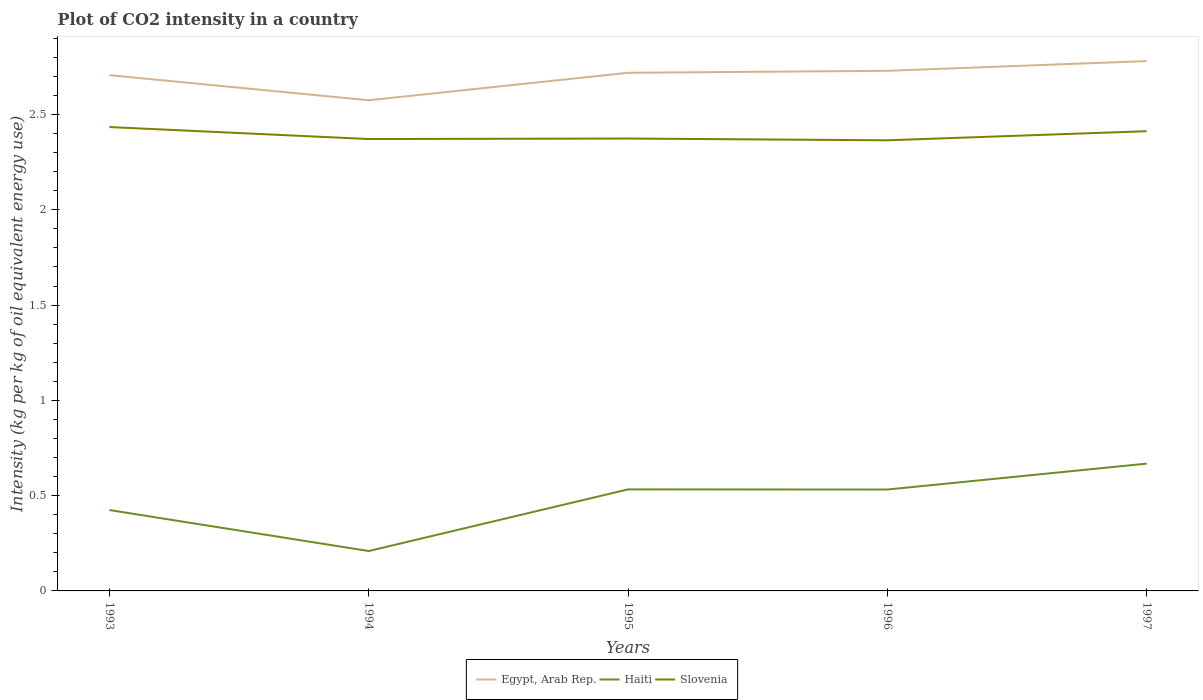How many different coloured lines are there?
Offer a terse response. 3. Does the line corresponding to Haiti intersect with the line corresponding to Egypt, Arab Rep.?
Ensure brevity in your answer.  No. Is the number of lines equal to the number of legend labels?
Keep it short and to the point. Yes. Across all years, what is the maximum CO2 intensity in in Haiti?
Provide a succinct answer. 0.21. What is the total CO2 intensity in in Slovenia in the graph?
Your answer should be very brief. 0.07. What is the difference between the highest and the second highest CO2 intensity in in Haiti?
Provide a short and direct response. 0.46. Is the CO2 intensity in in Haiti strictly greater than the CO2 intensity in in Slovenia over the years?
Your response must be concise. Yes. How many years are there in the graph?
Your answer should be very brief. 5. What is the difference between two consecutive major ticks on the Y-axis?
Provide a short and direct response. 0.5. Are the values on the major ticks of Y-axis written in scientific E-notation?
Give a very brief answer. No. Does the graph contain any zero values?
Offer a terse response. No. Where does the legend appear in the graph?
Offer a very short reply. Bottom center. How are the legend labels stacked?
Give a very brief answer. Horizontal. What is the title of the graph?
Keep it short and to the point. Plot of CO2 intensity in a country. Does "Bulgaria" appear as one of the legend labels in the graph?
Provide a succinct answer. No. What is the label or title of the X-axis?
Provide a short and direct response. Years. What is the label or title of the Y-axis?
Keep it short and to the point. Intensity (kg per kg of oil equivalent energy use). What is the Intensity (kg per kg of oil equivalent energy use) in Egypt, Arab Rep. in 1993?
Make the answer very short. 2.71. What is the Intensity (kg per kg of oil equivalent energy use) of Haiti in 1993?
Keep it short and to the point. 0.42. What is the Intensity (kg per kg of oil equivalent energy use) in Slovenia in 1993?
Your answer should be very brief. 2.43. What is the Intensity (kg per kg of oil equivalent energy use) of Egypt, Arab Rep. in 1994?
Offer a very short reply. 2.57. What is the Intensity (kg per kg of oil equivalent energy use) in Haiti in 1994?
Make the answer very short. 0.21. What is the Intensity (kg per kg of oil equivalent energy use) in Slovenia in 1994?
Ensure brevity in your answer.  2.37. What is the Intensity (kg per kg of oil equivalent energy use) of Egypt, Arab Rep. in 1995?
Make the answer very short. 2.72. What is the Intensity (kg per kg of oil equivalent energy use) in Haiti in 1995?
Offer a very short reply. 0.53. What is the Intensity (kg per kg of oil equivalent energy use) in Slovenia in 1995?
Give a very brief answer. 2.37. What is the Intensity (kg per kg of oil equivalent energy use) of Egypt, Arab Rep. in 1996?
Your response must be concise. 2.73. What is the Intensity (kg per kg of oil equivalent energy use) of Haiti in 1996?
Offer a terse response. 0.53. What is the Intensity (kg per kg of oil equivalent energy use) in Slovenia in 1996?
Give a very brief answer. 2.36. What is the Intensity (kg per kg of oil equivalent energy use) in Egypt, Arab Rep. in 1997?
Your response must be concise. 2.78. What is the Intensity (kg per kg of oil equivalent energy use) of Haiti in 1997?
Your answer should be compact. 0.67. What is the Intensity (kg per kg of oil equivalent energy use) in Slovenia in 1997?
Provide a succinct answer. 2.41. Across all years, what is the maximum Intensity (kg per kg of oil equivalent energy use) in Egypt, Arab Rep.?
Your answer should be compact. 2.78. Across all years, what is the maximum Intensity (kg per kg of oil equivalent energy use) of Haiti?
Ensure brevity in your answer.  0.67. Across all years, what is the maximum Intensity (kg per kg of oil equivalent energy use) of Slovenia?
Give a very brief answer. 2.43. Across all years, what is the minimum Intensity (kg per kg of oil equivalent energy use) in Egypt, Arab Rep.?
Make the answer very short. 2.57. Across all years, what is the minimum Intensity (kg per kg of oil equivalent energy use) in Haiti?
Keep it short and to the point. 0.21. Across all years, what is the minimum Intensity (kg per kg of oil equivalent energy use) of Slovenia?
Offer a very short reply. 2.36. What is the total Intensity (kg per kg of oil equivalent energy use) in Egypt, Arab Rep. in the graph?
Offer a very short reply. 13.51. What is the total Intensity (kg per kg of oil equivalent energy use) in Haiti in the graph?
Provide a short and direct response. 2.37. What is the total Intensity (kg per kg of oil equivalent energy use) of Slovenia in the graph?
Keep it short and to the point. 11.96. What is the difference between the Intensity (kg per kg of oil equivalent energy use) in Egypt, Arab Rep. in 1993 and that in 1994?
Give a very brief answer. 0.13. What is the difference between the Intensity (kg per kg of oil equivalent energy use) in Haiti in 1993 and that in 1994?
Keep it short and to the point. 0.22. What is the difference between the Intensity (kg per kg of oil equivalent energy use) of Slovenia in 1993 and that in 1994?
Your answer should be very brief. 0.06. What is the difference between the Intensity (kg per kg of oil equivalent energy use) of Egypt, Arab Rep. in 1993 and that in 1995?
Keep it short and to the point. -0.01. What is the difference between the Intensity (kg per kg of oil equivalent energy use) of Haiti in 1993 and that in 1995?
Provide a succinct answer. -0.11. What is the difference between the Intensity (kg per kg of oil equivalent energy use) of Slovenia in 1993 and that in 1995?
Give a very brief answer. 0.06. What is the difference between the Intensity (kg per kg of oil equivalent energy use) in Egypt, Arab Rep. in 1993 and that in 1996?
Your response must be concise. -0.02. What is the difference between the Intensity (kg per kg of oil equivalent energy use) of Haiti in 1993 and that in 1996?
Keep it short and to the point. -0.11. What is the difference between the Intensity (kg per kg of oil equivalent energy use) of Slovenia in 1993 and that in 1996?
Ensure brevity in your answer.  0.07. What is the difference between the Intensity (kg per kg of oil equivalent energy use) in Egypt, Arab Rep. in 1993 and that in 1997?
Provide a short and direct response. -0.07. What is the difference between the Intensity (kg per kg of oil equivalent energy use) in Haiti in 1993 and that in 1997?
Keep it short and to the point. -0.24. What is the difference between the Intensity (kg per kg of oil equivalent energy use) in Slovenia in 1993 and that in 1997?
Make the answer very short. 0.02. What is the difference between the Intensity (kg per kg of oil equivalent energy use) in Egypt, Arab Rep. in 1994 and that in 1995?
Provide a succinct answer. -0.14. What is the difference between the Intensity (kg per kg of oil equivalent energy use) of Haiti in 1994 and that in 1995?
Ensure brevity in your answer.  -0.32. What is the difference between the Intensity (kg per kg of oil equivalent energy use) in Slovenia in 1994 and that in 1995?
Provide a short and direct response. -0. What is the difference between the Intensity (kg per kg of oil equivalent energy use) of Egypt, Arab Rep. in 1994 and that in 1996?
Provide a short and direct response. -0.15. What is the difference between the Intensity (kg per kg of oil equivalent energy use) of Haiti in 1994 and that in 1996?
Your answer should be compact. -0.32. What is the difference between the Intensity (kg per kg of oil equivalent energy use) in Slovenia in 1994 and that in 1996?
Your answer should be very brief. 0.01. What is the difference between the Intensity (kg per kg of oil equivalent energy use) of Egypt, Arab Rep. in 1994 and that in 1997?
Keep it short and to the point. -0.21. What is the difference between the Intensity (kg per kg of oil equivalent energy use) in Haiti in 1994 and that in 1997?
Your answer should be compact. -0.46. What is the difference between the Intensity (kg per kg of oil equivalent energy use) of Slovenia in 1994 and that in 1997?
Your response must be concise. -0.04. What is the difference between the Intensity (kg per kg of oil equivalent energy use) in Egypt, Arab Rep. in 1995 and that in 1996?
Ensure brevity in your answer.  -0.01. What is the difference between the Intensity (kg per kg of oil equivalent energy use) of Haiti in 1995 and that in 1996?
Provide a short and direct response. 0. What is the difference between the Intensity (kg per kg of oil equivalent energy use) in Slovenia in 1995 and that in 1996?
Provide a short and direct response. 0.01. What is the difference between the Intensity (kg per kg of oil equivalent energy use) of Egypt, Arab Rep. in 1995 and that in 1997?
Offer a terse response. -0.06. What is the difference between the Intensity (kg per kg of oil equivalent energy use) of Haiti in 1995 and that in 1997?
Ensure brevity in your answer.  -0.14. What is the difference between the Intensity (kg per kg of oil equivalent energy use) in Slovenia in 1995 and that in 1997?
Offer a very short reply. -0.04. What is the difference between the Intensity (kg per kg of oil equivalent energy use) of Egypt, Arab Rep. in 1996 and that in 1997?
Provide a short and direct response. -0.05. What is the difference between the Intensity (kg per kg of oil equivalent energy use) in Haiti in 1996 and that in 1997?
Offer a terse response. -0.14. What is the difference between the Intensity (kg per kg of oil equivalent energy use) in Slovenia in 1996 and that in 1997?
Your answer should be compact. -0.05. What is the difference between the Intensity (kg per kg of oil equivalent energy use) of Egypt, Arab Rep. in 1993 and the Intensity (kg per kg of oil equivalent energy use) of Haiti in 1994?
Make the answer very short. 2.5. What is the difference between the Intensity (kg per kg of oil equivalent energy use) in Egypt, Arab Rep. in 1993 and the Intensity (kg per kg of oil equivalent energy use) in Slovenia in 1994?
Give a very brief answer. 0.34. What is the difference between the Intensity (kg per kg of oil equivalent energy use) in Haiti in 1993 and the Intensity (kg per kg of oil equivalent energy use) in Slovenia in 1994?
Ensure brevity in your answer.  -1.95. What is the difference between the Intensity (kg per kg of oil equivalent energy use) in Egypt, Arab Rep. in 1993 and the Intensity (kg per kg of oil equivalent energy use) in Haiti in 1995?
Provide a succinct answer. 2.17. What is the difference between the Intensity (kg per kg of oil equivalent energy use) of Egypt, Arab Rep. in 1993 and the Intensity (kg per kg of oil equivalent energy use) of Slovenia in 1995?
Your answer should be very brief. 0.33. What is the difference between the Intensity (kg per kg of oil equivalent energy use) in Haiti in 1993 and the Intensity (kg per kg of oil equivalent energy use) in Slovenia in 1995?
Your response must be concise. -1.95. What is the difference between the Intensity (kg per kg of oil equivalent energy use) in Egypt, Arab Rep. in 1993 and the Intensity (kg per kg of oil equivalent energy use) in Haiti in 1996?
Make the answer very short. 2.17. What is the difference between the Intensity (kg per kg of oil equivalent energy use) in Egypt, Arab Rep. in 1993 and the Intensity (kg per kg of oil equivalent energy use) in Slovenia in 1996?
Offer a very short reply. 0.34. What is the difference between the Intensity (kg per kg of oil equivalent energy use) of Haiti in 1993 and the Intensity (kg per kg of oil equivalent energy use) of Slovenia in 1996?
Offer a very short reply. -1.94. What is the difference between the Intensity (kg per kg of oil equivalent energy use) of Egypt, Arab Rep. in 1993 and the Intensity (kg per kg of oil equivalent energy use) of Haiti in 1997?
Provide a succinct answer. 2.04. What is the difference between the Intensity (kg per kg of oil equivalent energy use) in Egypt, Arab Rep. in 1993 and the Intensity (kg per kg of oil equivalent energy use) in Slovenia in 1997?
Your response must be concise. 0.29. What is the difference between the Intensity (kg per kg of oil equivalent energy use) in Haiti in 1993 and the Intensity (kg per kg of oil equivalent energy use) in Slovenia in 1997?
Offer a very short reply. -1.99. What is the difference between the Intensity (kg per kg of oil equivalent energy use) of Egypt, Arab Rep. in 1994 and the Intensity (kg per kg of oil equivalent energy use) of Haiti in 1995?
Provide a succinct answer. 2.04. What is the difference between the Intensity (kg per kg of oil equivalent energy use) in Egypt, Arab Rep. in 1994 and the Intensity (kg per kg of oil equivalent energy use) in Slovenia in 1995?
Your response must be concise. 0.2. What is the difference between the Intensity (kg per kg of oil equivalent energy use) of Haiti in 1994 and the Intensity (kg per kg of oil equivalent energy use) of Slovenia in 1995?
Your answer should be very brief. -2.16. What is the difference between the Intensity (kg per kg of oil equivalent energy use) in Egypt, Arab Rep. in 1994 and the Intensity (kg per kg of oil equivalent energy use) in Haiti in 1996?
Keep it short and to the point. 2.04. What is the difference between the Intensity (kg per kg of oil equivalent energy use) in Egypt, Arab Rep. in 1994 and the Intensity (kg per kg of oil equivalent energy use) in Slovenia in 1996?
Your response must be concise. 0.21. What is the difference between the Intensity (kg per kg of oil equivalent energy use) in Haiti in 1994 and the Intensity (kg per kg of oil equivalent energy use) in Slovenia in 1996?
Your response must be concise. -2.16. What is the difference between the Intensity (kg per kg of oil equivalent energy use) in Egypt, Arab Rep. in 1994 and the Intensity (kg per kg of oil equivalent energy use) in Haiti in 1997?
Your response must be concise. 1.91. What is the difference between the Intensity (kg per kg of oil equivalent energy use) of Egypt, Arab Rep. in 1994 and the Intensity (kg per kg of oil equivalent energy use) of Slovenia in 1997?
Offer a very short reply. 0.16. What is the difference between the Intensity (kg per kg of oil equivalent energy use) of Haiti in 1994 and the Intensity (kg per kg of oil equivalent energy use) of Slovenia in 1997?
Keep it short and to the point. -2.2. What is the difference between the Intensity (kg per kg of oil equivalent energy use) in Egypt, Arab Rep. in 1995 and the Intensity (kg per kg of oil equivalent energy use) in Haiti in 1996?
Keep it short and to the point. 2.19. What is the difference between the Intensity (kg per kg of oil equivalent energy use) of Egypt, Arab Rep. in 1995 and the Intensity (kg per kg of oil equivalent energy use) of Slovenia in 1996?
Ensure brevity in your answer.  0.35. What is the difference between the Intensity (kg per kg of oil equivalent energy use) of Haiti in 1995 and the Intensity (kg per kg of oil equivalent energy use) of Slovenia in 1996?
Ensure brevity in your answer.  -1.83. What is the difference between the Intensity (kg per kg of oil equivalent energy use) of Egypt, Arab Rep. in 1995 and the Intensity (kg per kg of oil equivalent energy use) of Haiti in 1997?
Provide a short and direct response. 2.05. What is the difference between the Intensity (kg per kg of oil equivalent energy use) of Egypt, Arab Rep. in 1995 and the Intensity (kg per kg of oil equivalent energy use) of Slovenia in 1997?
Ensure brevity in your answer.  0.31. What is the difference between the Intensity (kg per kg of oil equivalent energy use) of Haiti in 1995 and the Intensity (kg per kg of oil equivalent energy use) of Slovenia in 1997?
Offer a terse response. -1.88. What is the difference between the Intensity (kg per kg of oil equivalent energy use) of Egypt, Arab Rep. in 1996 and the Intensity (kg per kg of oil equivalent energy use) of Haiti in 1997?
Your answer should be compact. 2.06. What is the difference between the Intensity (kg per kg of oil equivalent energy use) in Egypt, Arab Rep. in 1996 and the Intensity (kg per kg of oil equivalent energy use) in Slovenia in 1997?
Give a very brief answer. 0.32. What is the difference between the Intensity (kg per kg of oil equivalent energy use) in Haiti in 1996 and the Intensity (kg per kg of oil equivalent energy use) in Slovenia in 1997?
Give a very brief answer. -1.88. What is the average Intensity (kg per kg of oil equivalent energy use) of Egypt, Arab Rep. per year?
Keep it short and to the point. 2.7. What is the average Intensity (kg per kg of oil equivalent energy use) of Haiti per year?
Provide a succinct answer. 0.47. What is the average Intensity (kg per kg of oil equivalent energy use) in Slovenia per year?
Ensure brevity in your answer.  2.39. In the year 1993, what is the difference between the Intensity (kg per kg of oil equivalent energy use) of Egypt, Arab Rep. and Intensity (kg per kg of oil equivalent energy use) of Haiti?
Offer a very short reply. 2.28. In the year 1993, what is the difference between the Intensity (kg per kg of oil equivalent energy use) in Egypt, Arab Rep. and Intensity (kg per kg of oil equivalent energy use) in Slovenia?
Offer a very short reply. 0.27. In the year 1993, what is the difference between the Intensity (kg per kg of oil equivalent energy use) in Haiti and Intensity (kg per kg of oil equivalent energy use) in Slovenia?
Offer a very short reply. -2.01. In the year 1994, what is the difference between the Intensity (kg per kg of oil equivalent energy use) of Egypt, Arab Rep. and Intensity (kg per kg of oil equivalent energy use) of Haiti?
Your answer should be compact. 2.37. In the year 1994, what is the difference between the Intensity (kg per kg of oil equivalent energy use) in Egypt, Arab Rep. and Intensity (kg per kg of oil equivalent energy use) in Slovenia?
Your response must be concise. 0.2. In the year 1994, what is the difference between the Intensity (kg per kg of oil equivalent energy use) of Haiti and Intensity (kg per kg of oil equivalent energy use) of Slovenia?
Your answer should be very brief. -2.16. In the year 1995, what is the difference between the Intensity (kg per kg of oil equivalent energy use) of Egypt, Arab Rep. and Intensity (kg per kg of oil equivalent energy use) of Haiti?
Your answer should be very brief. 2.19. In the year 1995, what is the difference between the Intensity (kg per kg of oil equivalent energy use) in Egypt, Arab Rep. and Intensity (kg per kg of oil equivalent energy use) in Slovenia?
Provide a succinct answer. 0.34. In the year 1995, what is the difference between the Intensity (kg per kg of oil equivalent energy use) in Haiti and Intensity (kg per kg of oil equivalent energy use) in Slovenia?
Give a very brief answer. -1.84. In the year 1996, what is the difference between the Intensity (kg per kg of oil equivalent energy use) in Egypt, Arab Rep. and Intensity (kg per kg of oil equivalent energy use) in Haiti?
Offer a terse response. 2.2. In the year 1996, what is the difference between the Intensity (kg per kg of oil equivalent energy use) in Egypt, Arab Rep. and Intensity (kg per kg of oil equivalent energy use) in Slovenia?
Provide a short and direct response. 0.36. In the year 1996, what is the difference between the Intensity (kg per kg of oil equivalent energy use) of Haiti and Intensity (kg per kg of oil equivalent energy use) of Slovenia?
Offer a terse response. -1.83. In the year 1997, what is the difference between the Intensity (kg per kg of oil equivalent energy use) in Egypt, Arab Rep. and Intensity (kg per kg of oil equivalent energy use) in Haiti?
Ensure brevity in your answer.  2.11. In the year 1997, what is the difference between the Intensity (kg per kg of oil equivalent energy use) in Egypt, Arab Rep. and Intensity (kg per kg of oil equivalent energy use) in Slovenia?
Provide a succinct answer. 0.37. In the year 1997, what is the difference between the Intensity (kg per kg of oil equivalent energy use) of Haiti and Intensity (kg per kg of oil equivalent energy use) of Slovenia?
Your answer should be compact. -1.74. What is the ratio of the Intensity (kg per kg of oil equivalent energy use) in Egypt, Arab Rep. in 1993 to that in 1994?
Offer a terse response. 1.05. What is the ratio of the Intensity (kg per kg of oil equivalent energy use) of Haiti in 1993 to that in 1994?
Your answer should be compact. 2.03. What is the ratio of the Intensity (kg per kg of oil equivalent energy use) in Slovenia in 1993 to that in 1994?
Your answer should be very brief. 1.03. What is the ratio of the Intensity (kg per kg of oil equivalent energy use) of Haiti in 1993 to that in 1995?
Give a very brief answer. 0.8. What is the ratio of the Intensity (kg per kg of oil equivalent energy use) of Slovenia in 1993 to that in 1995?
Your answer should be compact. 1.03. What is the ratio of the Intensity (kg per kg of oil equivalent energy use) in Haiti in 1993 to that in 1996?
Offer a very short reply. 0.8. What is the ratio of the Intensity (kg per kg of oil equivalent energy use) in Slovenia in 1993 to that in 1996?
Offer a terse response. 1.03. What is the ratio of the Intensity (kg per kg of oil equivalent energy use) in Egypt, Arab Rep. in 1993 to that in 1997?
Provide a succinct answer. 0.97. What is the ratio of the Intensity (kg per kg of oil equivalent energy use) in Haiti in 1993 to that in 1997?
Provide a short and direct response. 0.64. What is the ratio of the Intensity (kg per kg of oil equivalent energy use) of Egypt, Arab Rep. in 1994 to that in 1995?
Offer a very short reply. 0.95. What is the ratio of the Intensity (kg per kg of oil equivalent energy use) in Haiti in 1994 to that in 1995?
Provide a short and direct response. 0.39. What is the ratio of the Intensity (kg per kg of oil equivalent energy use) in Egypt, Arab Rep. in 1994 to that in 1996?
Ensure brevity in your answer.  0.94. What is the ratio of the Intensity (kg per kg of oil equivalent energy use) in Haiti in 1994 to that in 1996?
Your answer should be compact. 0.39. What is the ratio of the Intensity (kg per kg of oil equivalent energy use) of Egypt, Arab Rep. in 1994 to that in 1997?
Provide a short and direct response. 0.93. What is the ratio of the Intensity (kg per kg of oil equivalent energy use) in Haiti in 1994 to that in 1997?
Keep it short and to the point. 0.31. What is the ratio of the Intensity (kg per kg of oil equivalent energy use) of Slovenia in 1994 to that in 1997?
Your answer should be very brief. 0.98. What is the ratio of the Intensity (kg per kg of oil equivalent energy use) in Egypt, Arab Rep. in 1995 to that in 1996?
Give a very brief answer. 1. What is the ratio of the Intensity (kg per kg of oil equivalent energy use) of Egypt, Arab Rep. in 1995 to that in 1997?
Make the answer very short. 0.98. What is the ratio of the Intensity (kg per kg of oil equivalent energy use) in Haiti in 1995 to that in 1997?
Give a very brief answer. 0.8. What is the ratio of the Intensity (kg per kg of oil equivalent energy use) of Egypt, Arab Rep. in 1996 to that in 1997?
Offer a very short reply. 0.98. What is the ratio of the Intensity (kg per kg of oil equivalent energy use) of Haiti in 1996 to that in 1997?
Give a very brief answer. 0.8. What is the ratio of the Intensity (kg per kg of oil equivalent energy use) of Slovenia in 1996 to that in 1997?
Your response must be concise. 0.98. What is the difference between the highest and the second highest Intensity (kg per kg of oil equivalent energy use) in Egypt, Arab Rep.?
Make the answer very short. 0.05. What is the difference between the highest and the second highest Intensity (kg per kg of oil equivalent energy use) of Haiti?
Make the answer very short. 0.14. What is the difference between the highest and the second highest Intensity (kg per kg of oil equivalent energy use) of Slovenia?
Provide a succinct answer. 0.02. What is the difference between the highest and the lowest Intensity (kg per kg of oil equivalent energy use) of Egypt, Arab Rep.?
Make the answer very short. 0.21. What is the difference between the highest and the lowest Intensity (kg per kg of oil equivalent energy use) of Haiti?
Your response must be concise. 0.46. What is the difference between the highest and the lowest Intensity (kg per kg of oil equivalent energy use) in Slovenia?
Offer a terse response. 0.07. 